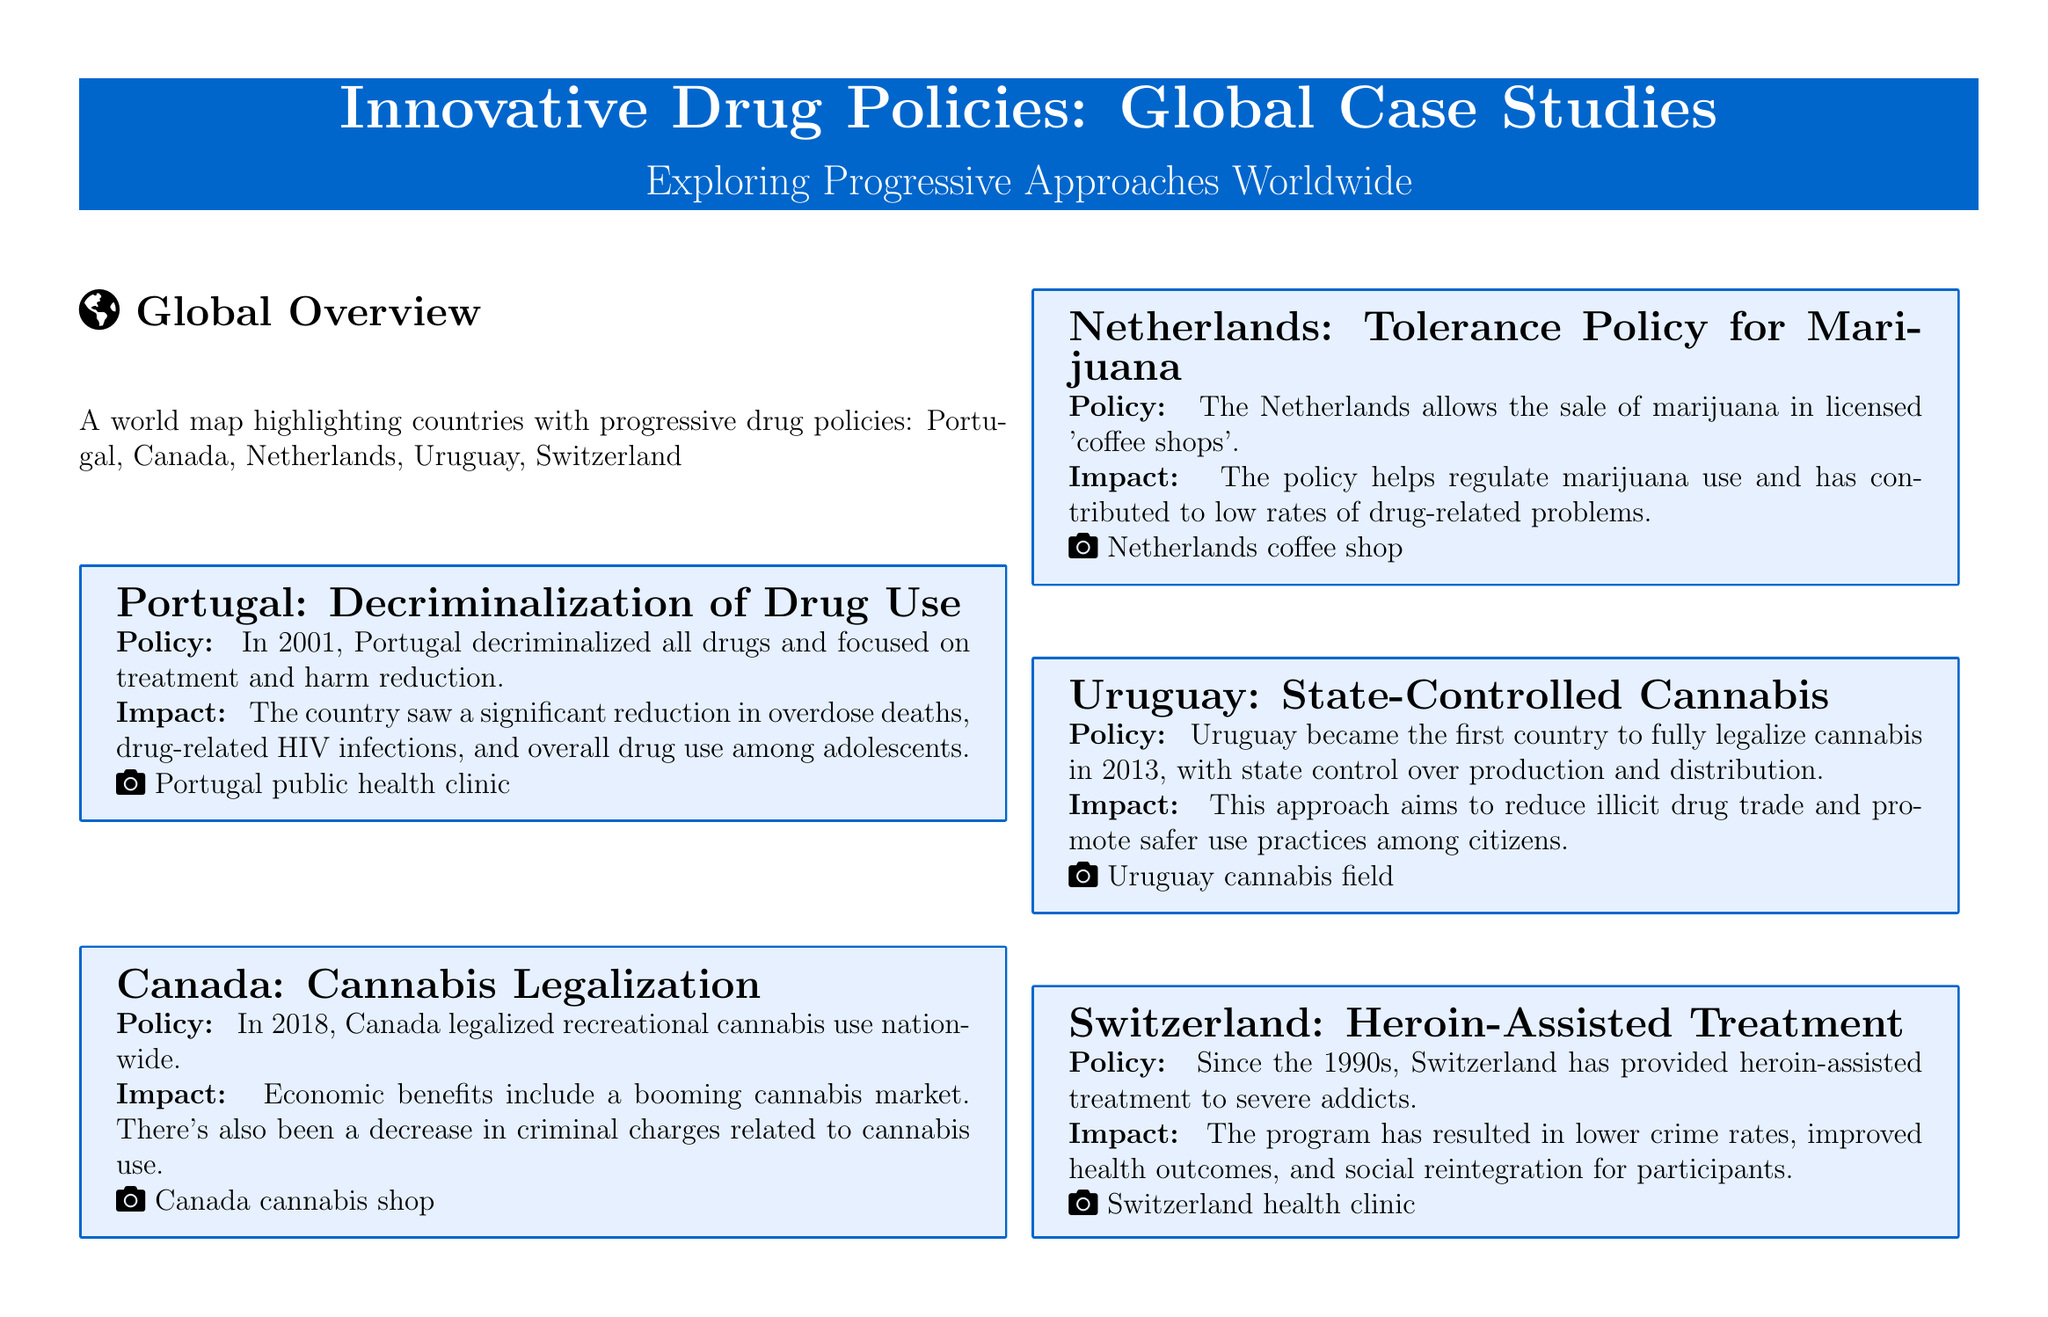What year did Portugal decriminalize all drugs? The document states that Portugal decriminalized all drugs in 2001.
Answer: 2001 What is the impact of Canada’s cannabis legalization? The document mentions that Canada experienced economic benefits and a decrease in criminal charges related to cannabis use.
Answer: Economic benefits What type of cannabis policy does the Netherlands have? According to the document, the Netherlands has a tolerance policy for marijuana that allows sale in licensed coffee shops.
Answer: Tolerance policy for marijuana What year did Uruguay fully legalize cannabis? The document indicates that Uruguay fully legalized cannabis in 2013.
Answer: 2013 What approach is used in Switzerland for severe addicts? The document states that Switzerland provides heroin-assisted treatment for severe addicts.
Answer: Heroin-assisted treatment What was the focus of Portugal's drug policy after decriminalization? The document highlights that after decriminalization, Portugal focused on treatment and harm reduction.
Answer: Treatment and harm reduction How has Switzerland's drug policy affected crime rates? The document explains that the program has resulted in lower crime rates.
Answer: Lower crime rates Which country highlighted has a state-controlled cannabis policy? The document reveals that Uruguay has a state-controlled cannabis policy.
Answer: Uruguay 